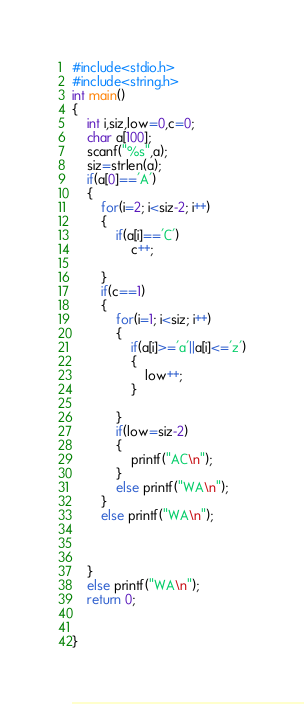<code> <loc_0><loc_0><loc_500><loc_500><_C_>#include<stdio.h>
#include<string.h>
int main()
{
    int i,siz,low=0,c=0;
    char a[100];
    scanf("%s",a);
    siz=strlen(a);
    if(a[0]=='A')
    {
        for(i=2; i<siz-2; i++)
        {
            if(a[i]=='C')
                c++;

        }
        if(c==1)
        {
            for(i=1; i<siz; i++)
            {
                if(a[i]>='a'||a[i]<='z')
                {
                    low++;
                }

            }
            if(low=siz-2)
            {
                printf("AC\n");
            }
            else printf("WA\n");
        }
        else printf("WA\n");



    }
    else printf("WA\n");
    return 0;


}</code> 